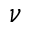Convert formula to latex. <formula><loc_0><loc_0><loc_500><loc_500>\nu</formula> 